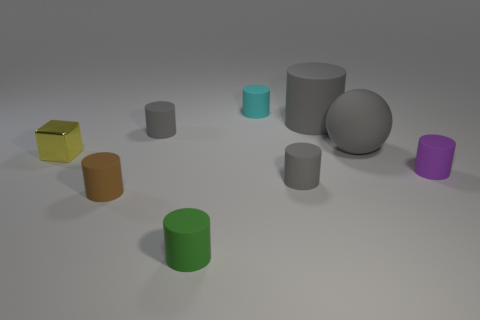Subtract all yellow cubes. How many gray cylinders are left? 3 Subtract all green cylinders. How many cylinders are left? 6 Subtract all cyan cylinders. How many cylinders are left? 6 Subtract 3 cylinders. How many cylinders are left? 4 Subtract all yellow cylinders. Subtract all red balls. How many cylinders are left? 7 Subtract all cylinders. How many objects are left? 2 Add 3 gray things. How many gray things are left? 7 Add 7 large brown matte cubes. How many large brown matte cubes exist? 7 Subtract 1 brown cylinders. How many objects are left? 8 Subtract all tiny gray cylinders. Subtract all large things. How many objects are left? 5 